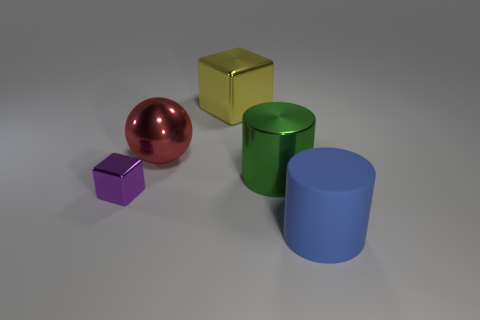Is there anything else that is the same material as the big blue cylinder?
Offer a very short reply. No. Is there any other thing that has the same size as the purple shiny object?
Your response must be concise. No. There is a object that is left of the metal ball; is its shape the same as the metal thing behind the red ball?
Make the answer very short. Yes. How many objects are either big balls or big things behind the small purple block?
Your response must be concise. 3. How many other objects are there of the same shape as the matte object?
Provide a short and direct response. 1. Do the big thing that is behind the big red metal sphere and the big sphere have the same material?
Ensure brevity in your answer.  Yes. How many things are either green shiny cylinders or cyan rubber cubes?
Provide a short and direct response. 1. There is another object that is the same shape as the green shiny thing; what size is it?
Give a very brief answer. Large. How big is the red object?
Your answer should be compact. Large. Are there more blue cylinders that are behind the red thing than large cyan metallic blocks?
Your response must be concise. No. 